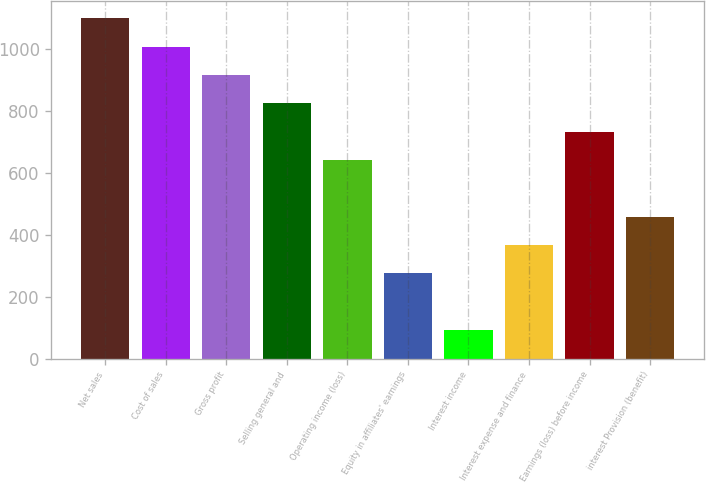Convert chart. <chart><loc_0><loc_0><loc_500><loc_500><bar_chart><fcel>Net sales<fcel>Cost of sales<fcel>Gross profit<fcel>Selling general and<fcel>Operating income (loss)<fcel>Equity in affiliates' earnings<fcel>Interest income<fcel>Interest expense and finance<fcel>Earnings (loss) before income<fcel>interest Provision (benefit)<nl><fcel>1099.39<fcel>1007.8<fcel>916.21<fcel>824.62<fcel>641.44<fcel>275.08<fcel>91.9<fcel>366.67<fcel>733.03<fcel>458.26<nl></chart> 